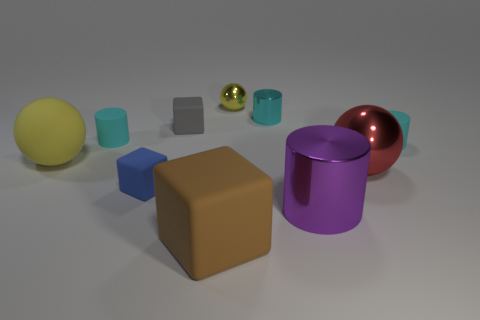How many rubber objects are large gray objects or tiny cylinders?
Provide a short and direct response. 2. What is the material of the red sphere that is the same size as the purple metal cylinder?
Ensure brevity in your answer.  Metal. Are there any red cylinders that have the same material as the purple thing?
Give a very brief answer. No. There is a cyan matte object to the right of the tiny block in front of the tiny cyan matte thing that is left of the red object; what is its shape?
Ensure brevity in your answer.  Cylinder. Do the matte sphere and the rubber block in front of the blue rubber thing have the same size?
Your answer should be very brief. Yes. The big object that is behind the large shiny cylinder and to the right of the big brown matte cube has what shape?
Offer a terse response. Sphere. How many small objects are brown things or shiny cylinders?
Keep it short and to the point. 1. Are there the same number of rubber objects that are behind the tiny sphere and small objects behind the cyan metal object?
Ensure brevity in your answer.  No. What number of other objects are the same color as the small ball?
Keep it short and to the point. 1. Are there the same number of small cyan cylinders in front of the large rubber block and big yellow metallic balls?
Make the answer very short. Yes. 